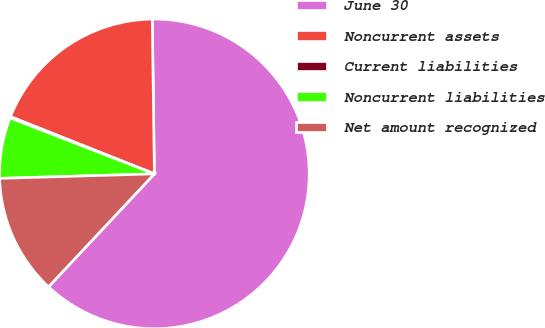Convert chart. <chart><loc_0><loc_0><loc_500><loc_500><pie_chart><fcel>June 30<fcel>Noncurrent assets<fcel>Current liabilities<fcel>Noncurrent liabilities<fcel>Net amount recognized<nl><fcel>62.2%<fcel>18.76%<fcel>0.14%<fcel>6.35%<fcel>12.55%<nl></chart> 